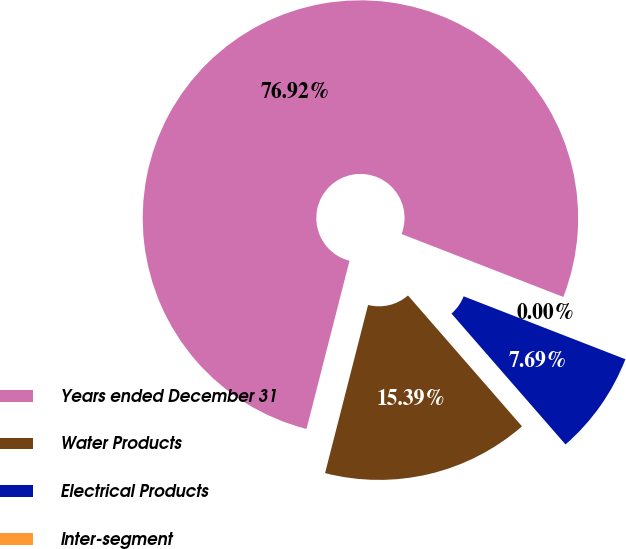Convert chart to OTSL. <chart><loc_0><loc_0><loc_500><loc_500><pie_chart><fcel>Years ended December 31<fcel>Water Products<fcel>Electrical Products<fcel>Inter-segment<nl><fcel>76.92%<fcel>15.39%<fcel>7.69%<fcel>0.0%<nl></chart> 